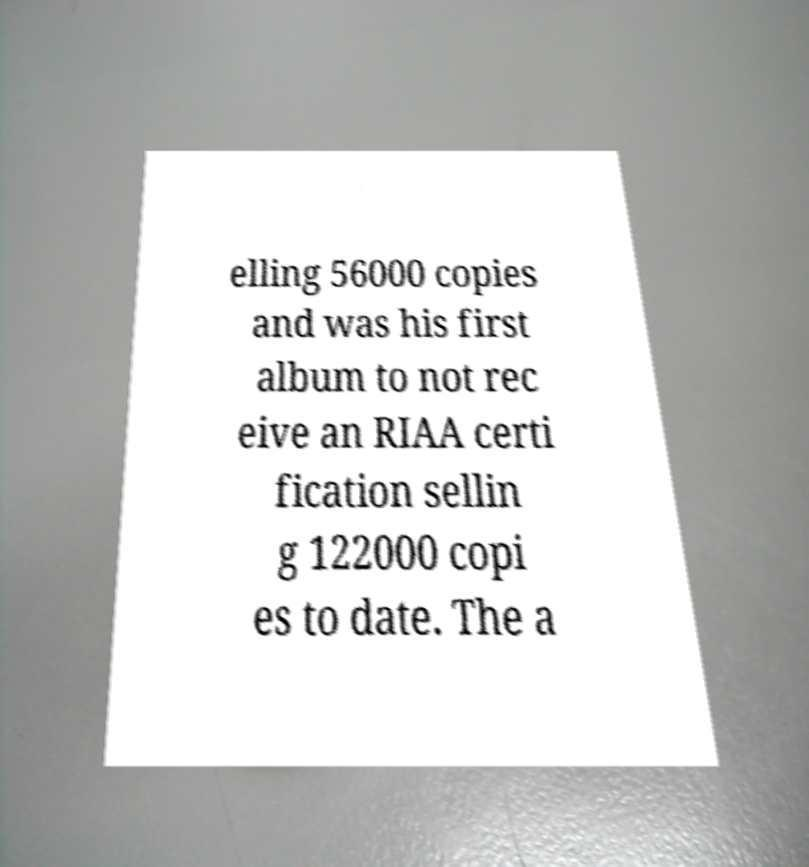For documentation purposes, I need the text within this image transcribed. Could you provide that? elling 56000 copies and was his first album to not rec eive an RIAA certi fication sellin g 122000 copi es to date. The a 